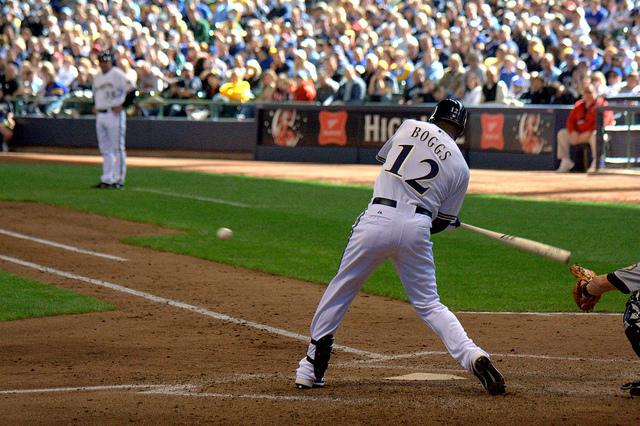What is the name of the batter?
Keep it brief. Boggs. Can you see the pitcher?
Keep it brief. No. Is Boggs a right-handed hitter?
Concise answer only. Yes. What number is the batter?
Keep it brief. 12. What is the player's number?
Keep it brief. 12. What is the batter's number?
Concise answer only. 12. What is the last name of the player batting?
Quick response, please. Boggs. What number is on the batter's jersey?
Keep it brief. 12. 